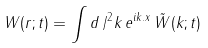Convert formula to latex. <formula><loc_0><loc_0><loc_500><loc_500>W ( r ; t ) = \int d \, / ^ { 2 } k \, e ^ { i { k } . { x } } \, { \tilde { W } } ( { k } ; t )</formula> 